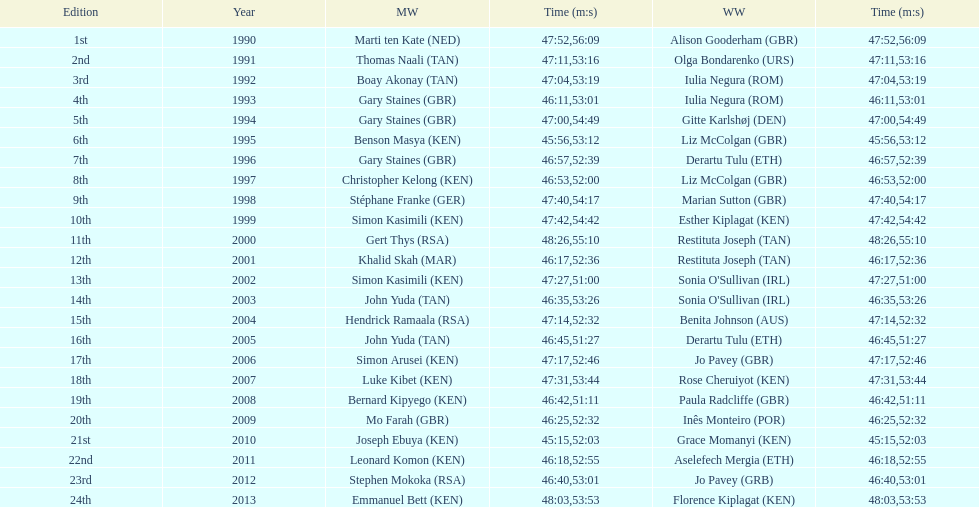Who is the male winner listed before gert thys? Simon Kasimili. 